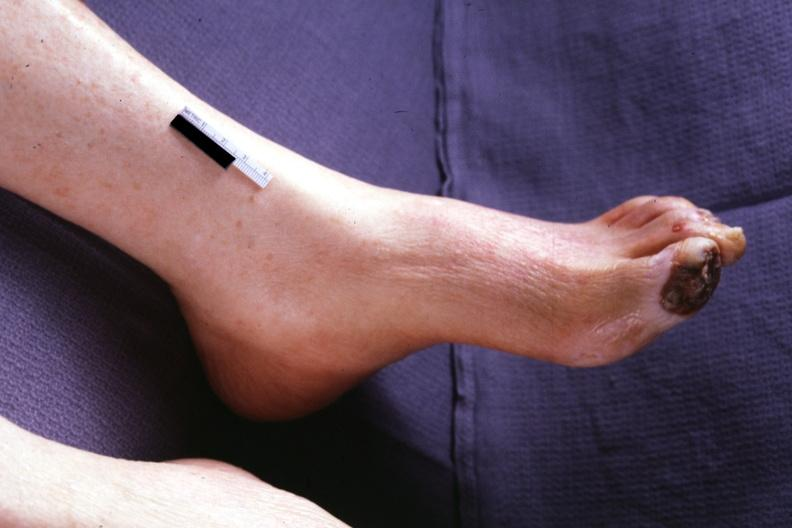what does this image show?
Answer the question using a single word or phrase. Typical gangrene 